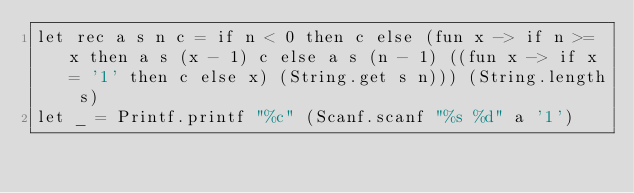<code> <loc_0><loc_0><loc_500><loc_500><_OCaml_>let rec a s n c = if n < 0 then c else (fun x -> if n >= x then a s (x - 1) c else a s (n - 1) ((fun x -> if x = '1' then c else x) (String.get s n))) (String.length s)
let _ = Printf.printf "%c" (Scanf.scanf "%s %d" a '1')</code> 